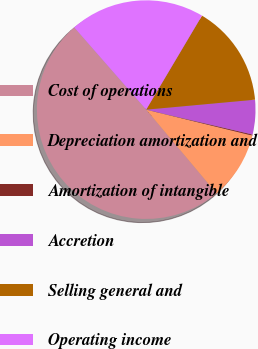<chart> <loc_0><loc_0><loc_500><loc_500><pie_chart><fcel>Cost of operations<fcel>Depreciation amortization and<fcel>Amortization of intangible<fcel>Accretion<fcel>Selling general and<fcel>Operating income<nl><fcel>49.67%<fcel>10.07%<fcel>0.16%<fcel>5.11%<fcel>15.02%<fcel>19.97%<nl></chart> 